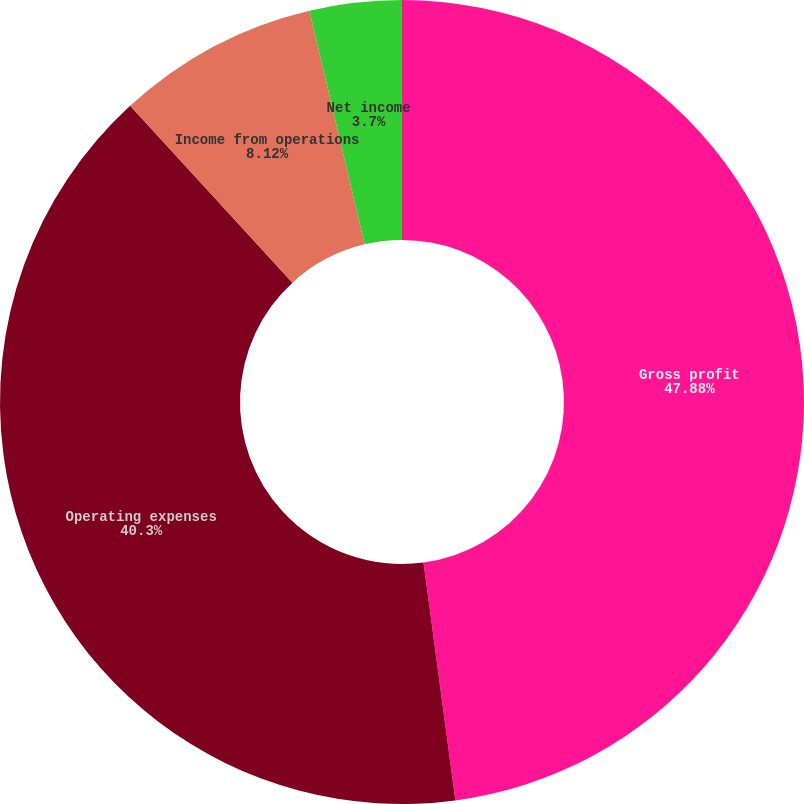Convert chart to OTSL. <chart><loc_0><loc_0><loc_500><loc_500><pie_chart><fcel>Gross profit<fcel>Operating expenses<fcel>Income from operations<fcel>Net income<nl><fcel>47.88%<fcel>40.3%<fcel>8.12%<fcel>3.7%<nl></chart> 